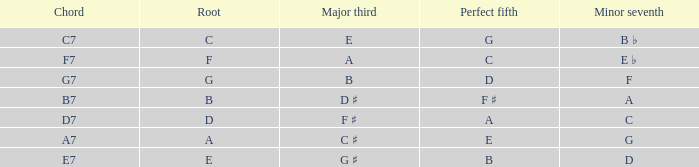What is the Chord with a Minor that is seventh of f? G7. 